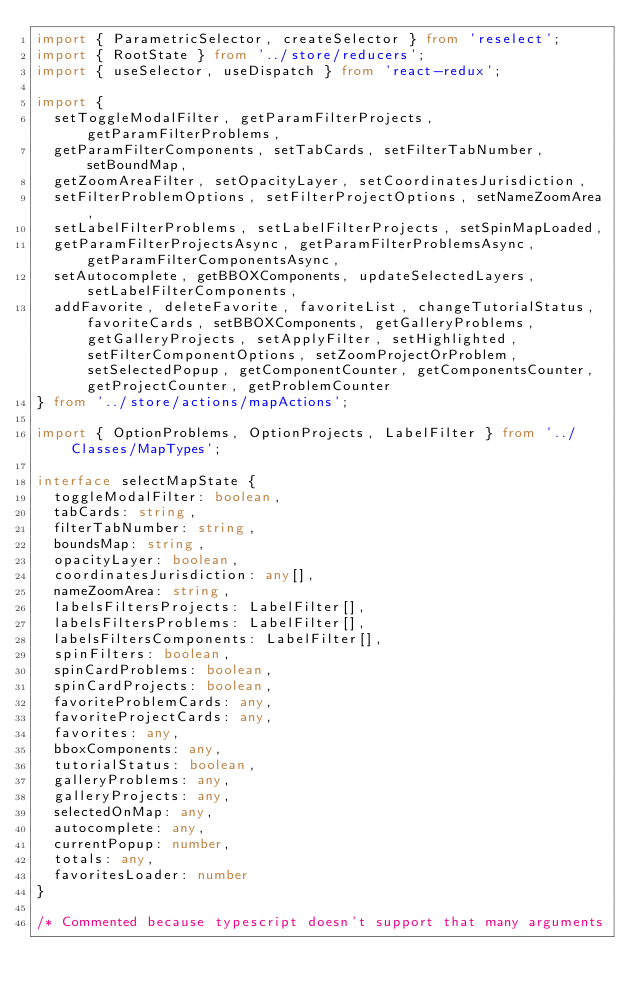Convert code to text. <code><loc_0><loc_0><loc_500><loc_500><_TypeScript_>import { ParametricSelector, createSelector } from 'reselect';
import { RootState } from '../store/reducers';
import { useSelector, useDispatch } from 'react-redux';

import {
  setToggleModalFilter, getParamFilterProjects, getParamFilterProblems,
  getParamFilterComponents, setTabCards, setFilterTabNumber, setBoundMap,
  getZoomAreaFilter, setOpacityLayer, setCoordinatesJurisdiction,
  setFilterProblemOptions, setFilterProjectOptions, setNameZoomArea,
  setLabelFilterProblems, setLabelFilterProjects, setSpinMapLoaded,
  getParamFilterProjectsAsync, getParamFilterProblemsAsync, getParamFilterComponentsAsync,
  setAutocomplete, getBBOXComponents, updateSelectedLayers, setLabelFilterComponents,
  addFavorite, deleteFavorite, favoriteList, changeTutorialStatus, favoriteCards, setBBOXComponents, getGalleryProblems, getGalleryProjects, setApplyFilter, setHighlighted, setFilterComponentOptions, setZoomProjectOrProblem, setSelectedPopup, getComponentCounter, getComponentsCounter, getProjectCounter, getProblemCounter
} from '../store/actions/mapActions';

import { OptionProblems, OptionProjects, LabelFilter } from '../Classes/MapTypes';

interface selectMapState {
  toggleModalFilter: boolean,
  tabCards: string,
  filterTabNumber: string,
  boundsMap: string,
  opacityLayer: boolean,
  coordinatesJurisdiction: any[],
  nameZoomArea: string,
  labelsFiltersProjects: LabelFilter[],
  labelsFiltersProblems: LabelFilter[],
  labelsFiltersComponents: LabelFilter[],
  spinFilters: boolean,
  spinCardProblems: boolean,
  spinCardProjects: boolean,
  favoriteProblemCards: any,
  favoriteProjectCards: any,
  favorites: any,
  bboxComponents: any,
  tutorialStatus: boolean,
  galleryProblems: any,
  galleryProjects: any,
  selectedOnMap: any,
  autocomplete: any,
  currentPopup: number,
  totals: any,
  favoritesLoader: number
}

/* Commented because typescript doesn't support that many arguments</code> 